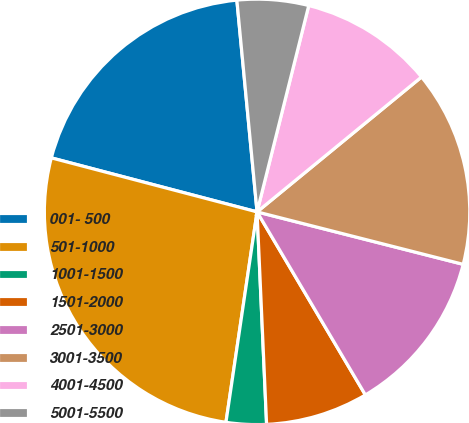<chart> <loc_0><loc_0><loc_500><loc_500><pie_chart><fcel>001- 500<fcel>501-1000<fcel>1001-1500<fcel>1501-2000<fcel>2501-3000<fcel>3001-3500<fcel>4001-4500<fcel>5001-5500<nl><fcel>19.4%<fcel>26.75%<fcel>3.05%<fcel>7.79%<fcel>12.53%<fcel>14.9%<fcel>10.16%<fcel>5.42%<nl></chart> 